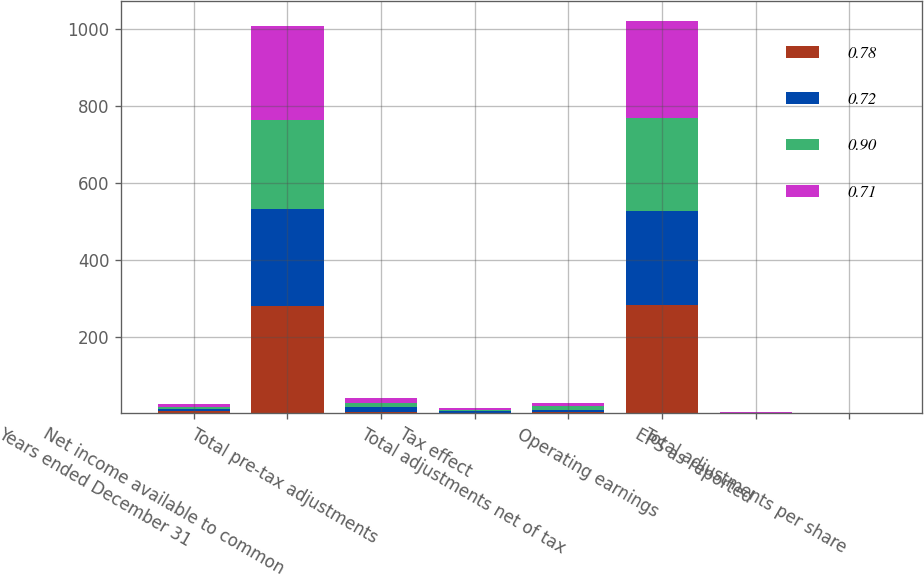Convert chart to OTSL. <chart><loc_0><loc_0><loc_500><loc_500><stacked_bar_chart><ecel><fcel>Years ended December 31<fcel>Net income available to common<fcel>Total pre-tax adjustments<fcel>Tax effect<fcel>Total adjustments net of tax<fcel>Operating earnings<fcel>EPS as reported<fcel>Total adjustments per share<nl><fcel>0.78<fcel>5.95<fcel>279.2<fcel>4.7<fcel>1.6<fcel>3.1<fcel>282.3<fcel>0.92<fcel>0.01<nl><fcel>0.72<fcel>5.95<fcel>251.7<fcel>11.1<fcel>3.9<fcel>7.2<fcel>244.5<fcel>0.84<fcel>0.02<nl><fcel>0.9<fcel>5.95<fcel>232.4<fcel>12.7<fcel>4<fcel>8.7<fcel>241.1<fcel>0.74<fcel>0.03<nl><fcel>0.71<fcel>5.95<fcel>245.3<fcel>12.7<fcel>4.1<fcel>8.6<fcel>253.9<fcel>0.72<fcel>0.03<nl></chart> 